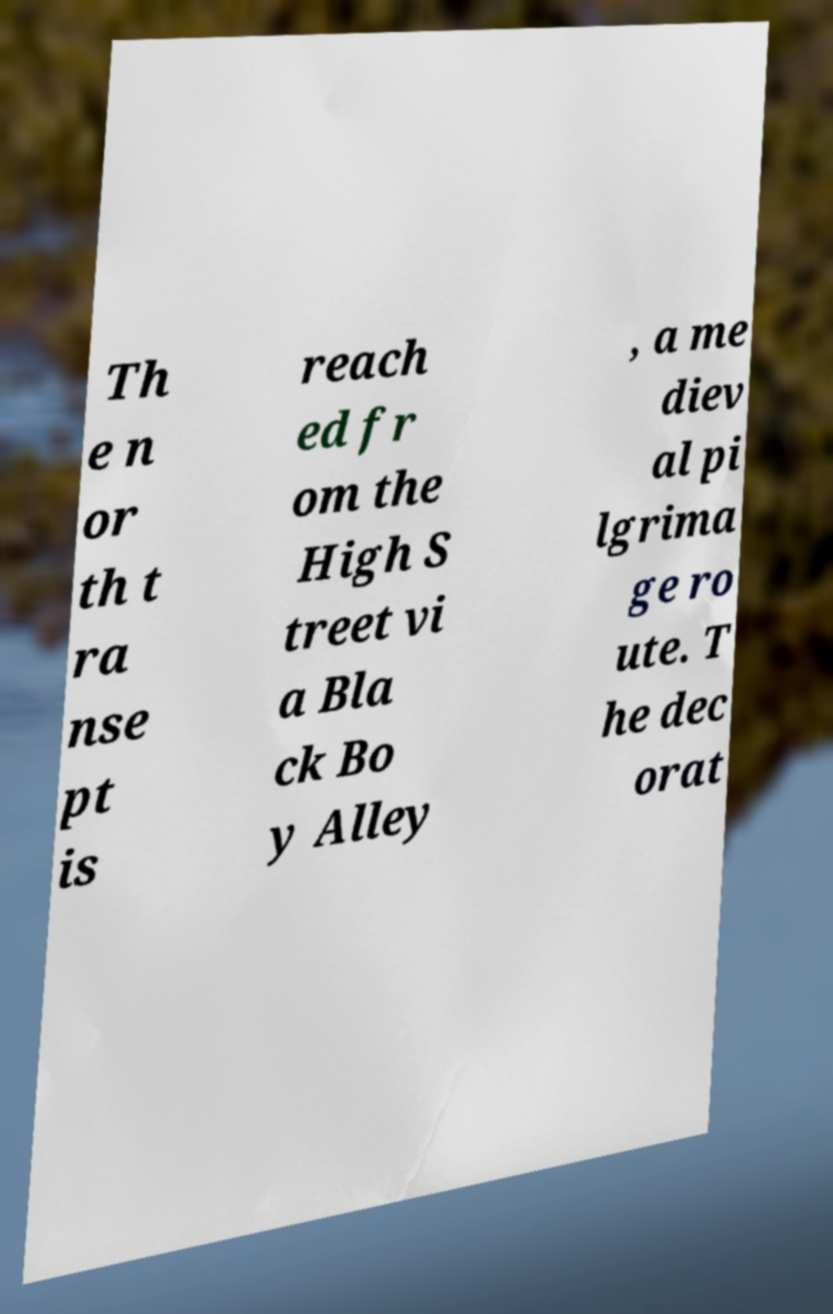Could you assist in decoding the text presented in this image and type it out clearly? Th e n or th t ra nse pt is reach ed fr om the High S treet vi a Bla ck Bo y Alley , a me diev al pi lgrima ge ro ute. T he dec orat 